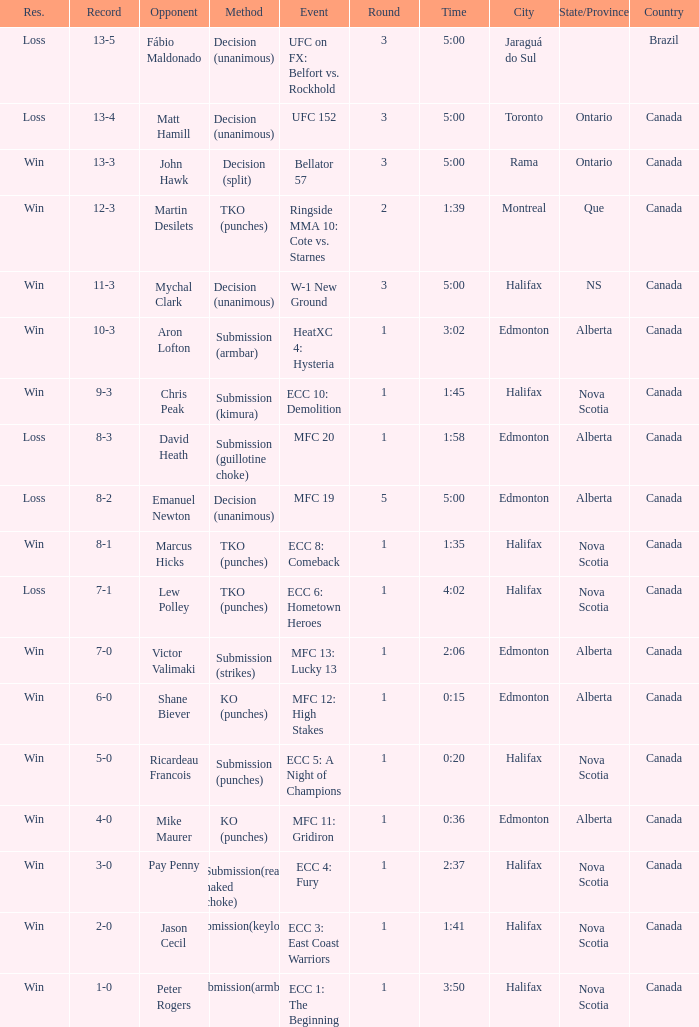What is the portion of the fight involving emanuel newton as the opposition? 5.0. 